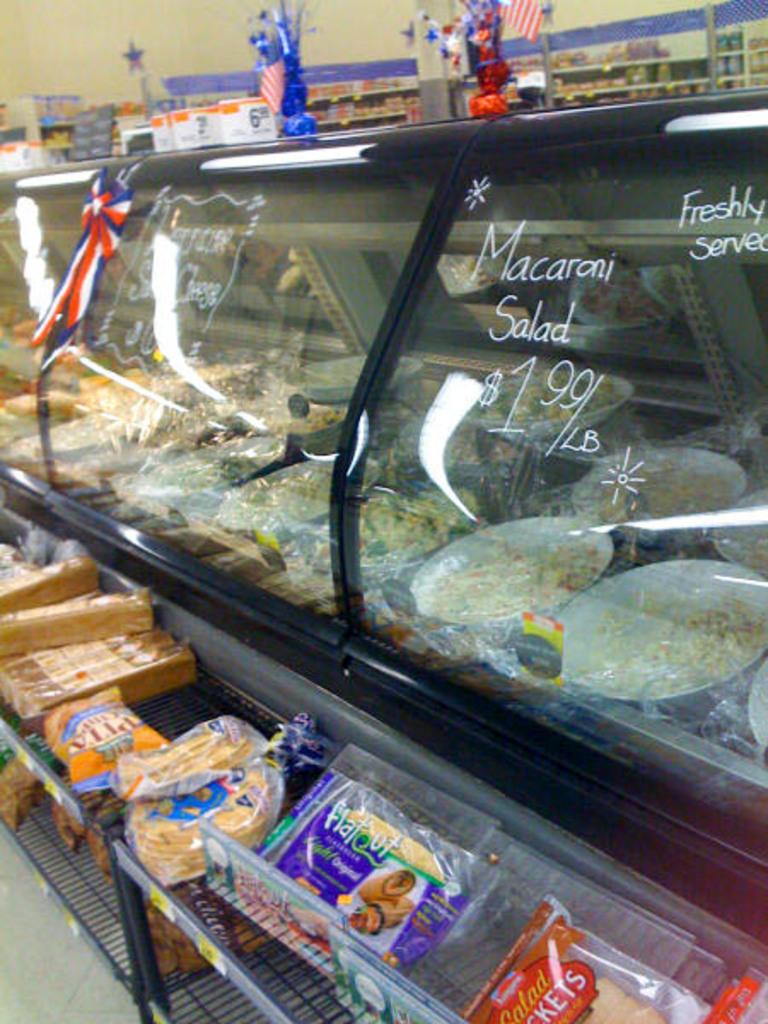What is 1.99?
Keep it short and to the point. Macaroni salad. Are the salads freshly served?
Give a very brief answer. Yes. 